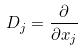<formula> <loc_0><loc_0><loc_500><loc_500>D _ { j } = \frac { \partial } { \partial x _ { j } }</formula> 